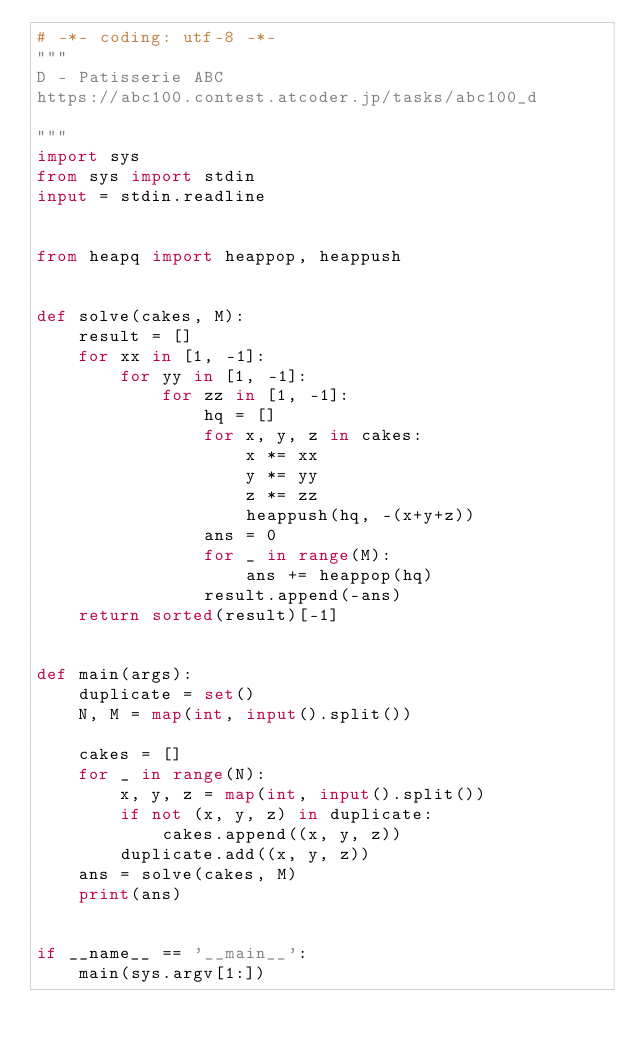Convert code to text. <code><loc_0><loc_0><loc_500><loc_500><_Python_># -*- coding: utf-8 -*-
"""
D - Patisserie ABC
https://abc100.contest.atcoder.jp/tasks/abc100_d

"""
import sys
from sys import stdin
input = stdin.readline


from heapq import heappop, heappush


def solve(cakes, M):
    result = []
    for xx in [1, -1]:
        for yy in [1, -1]:
            for zz in [1, -1]:
                hq = []
                for x, y, z in cakes:
                    x *= xx
                    y *= yy
                    z *= zz
                    heappush(hq, -(x+y+z))
                ans = 0
                for _ in range(M):
                    ans += heappop(hq)
                result.append(-ans)
    return sorted(result)[-1]


def main(args):
    duplicate = set()
    N, M = map(int, input().split())

    cakes = []
    for _ in range(N):
        x, y, z = map(int, input().split())
        if not (x, y, z) in duplicate:
            cakes.append((x, y, z))
        duplicate.add((x, y, z))
    ans = solve(cakes, M)
    print(ans)


if __name__ == '__main__':
    main(sys.argv[1:])
</code> 